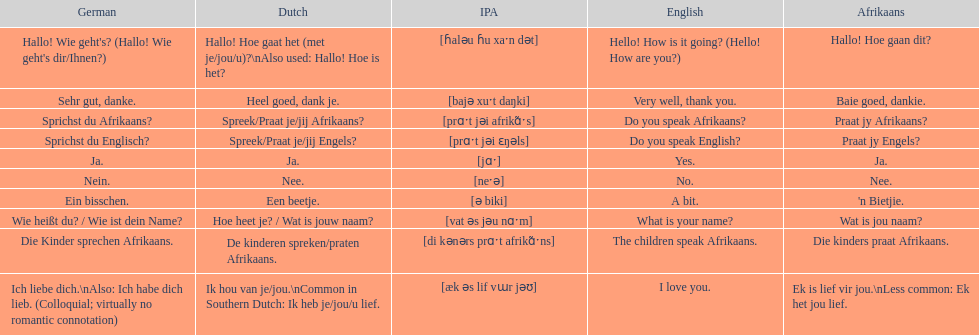Translate the following into german: die kinders praat afrikaans. Die Kinder sprechen Afrikaans. 